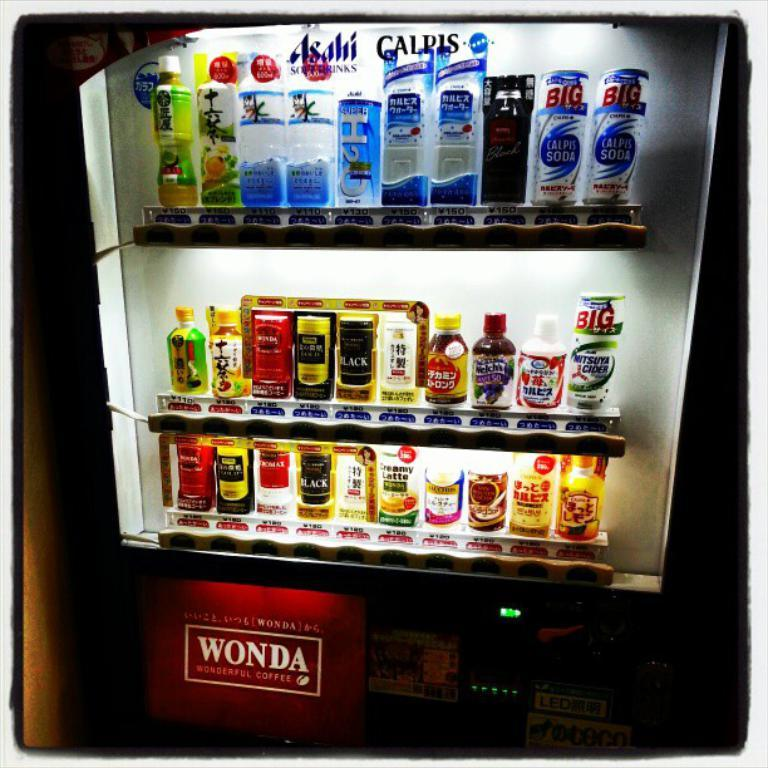<image>
Create a compact narrative representing the image presented. a machine that has the word Wonda on it 